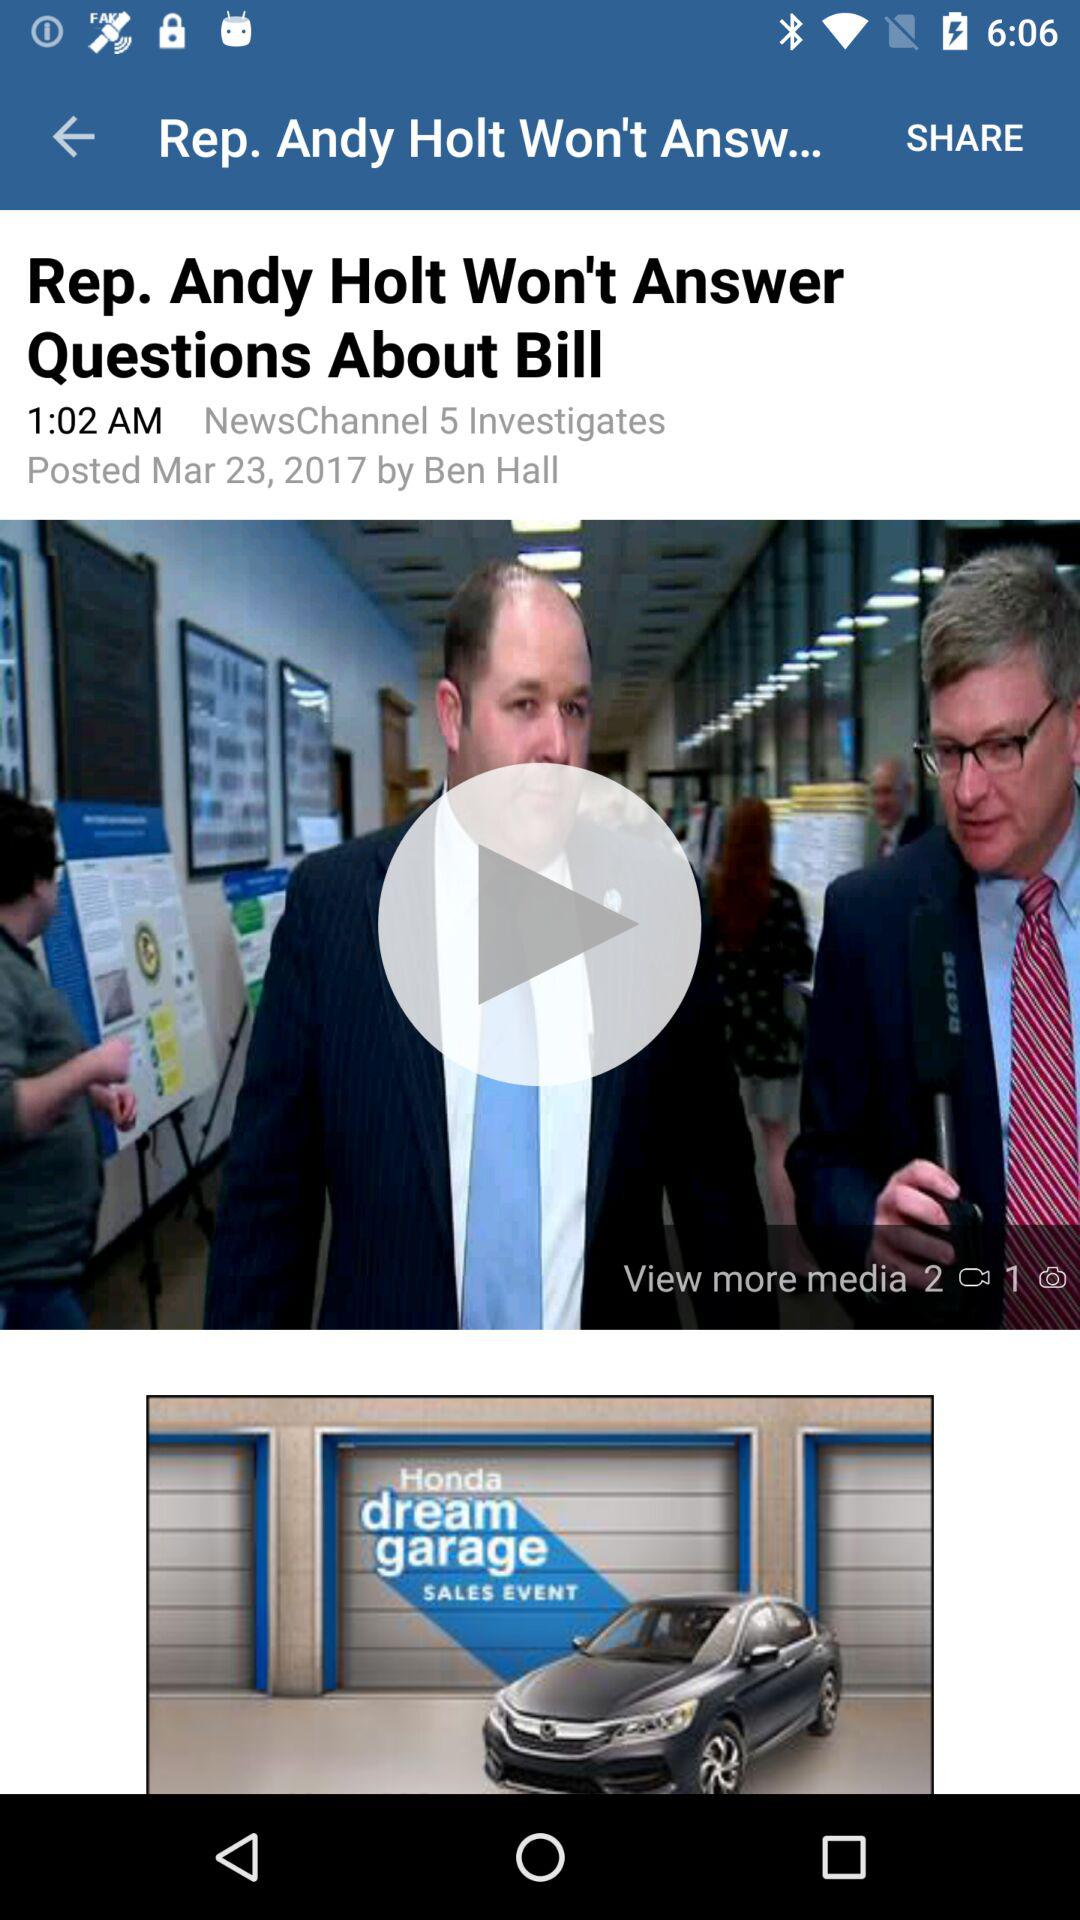What is the headline? The headline is "Rep. Andy Holt Won't Answer Questions About Bill". 